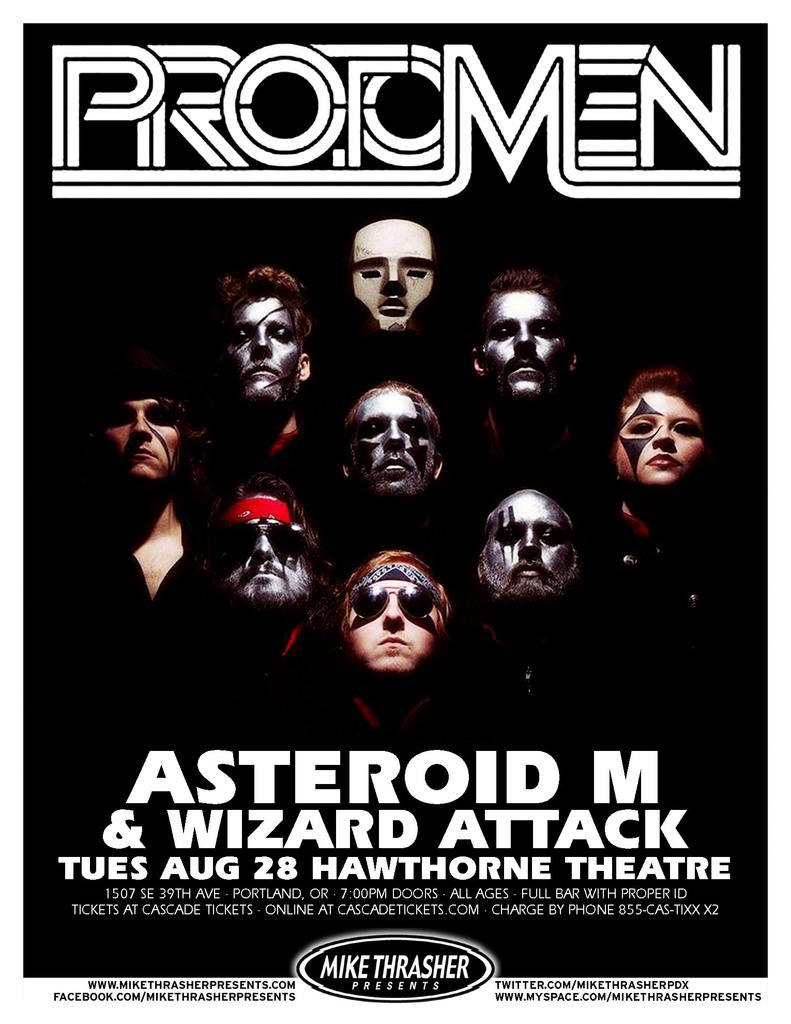<image>
Give a short and clear explanation of the subsequent image. The Protomen flier is promoting their August 28 show. 